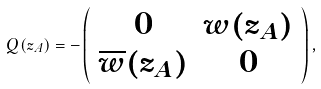<formula> <loc_0><loc_0><loc_500><loc_500>Q ( z _ { A } ) = - \left ( \begin{array} { c c } 0 & w ( z _ { A } ) \\ \overline { w } ( z _ { A } ) & 0 \\ \end{array} \right ) ,</formula> 